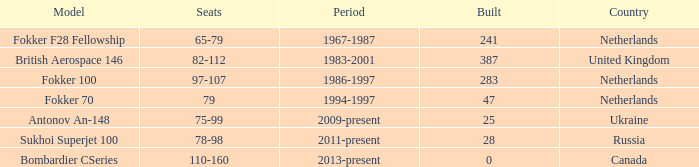During which time period were 241 fokker 70 model cabins built? 1994-1997. 